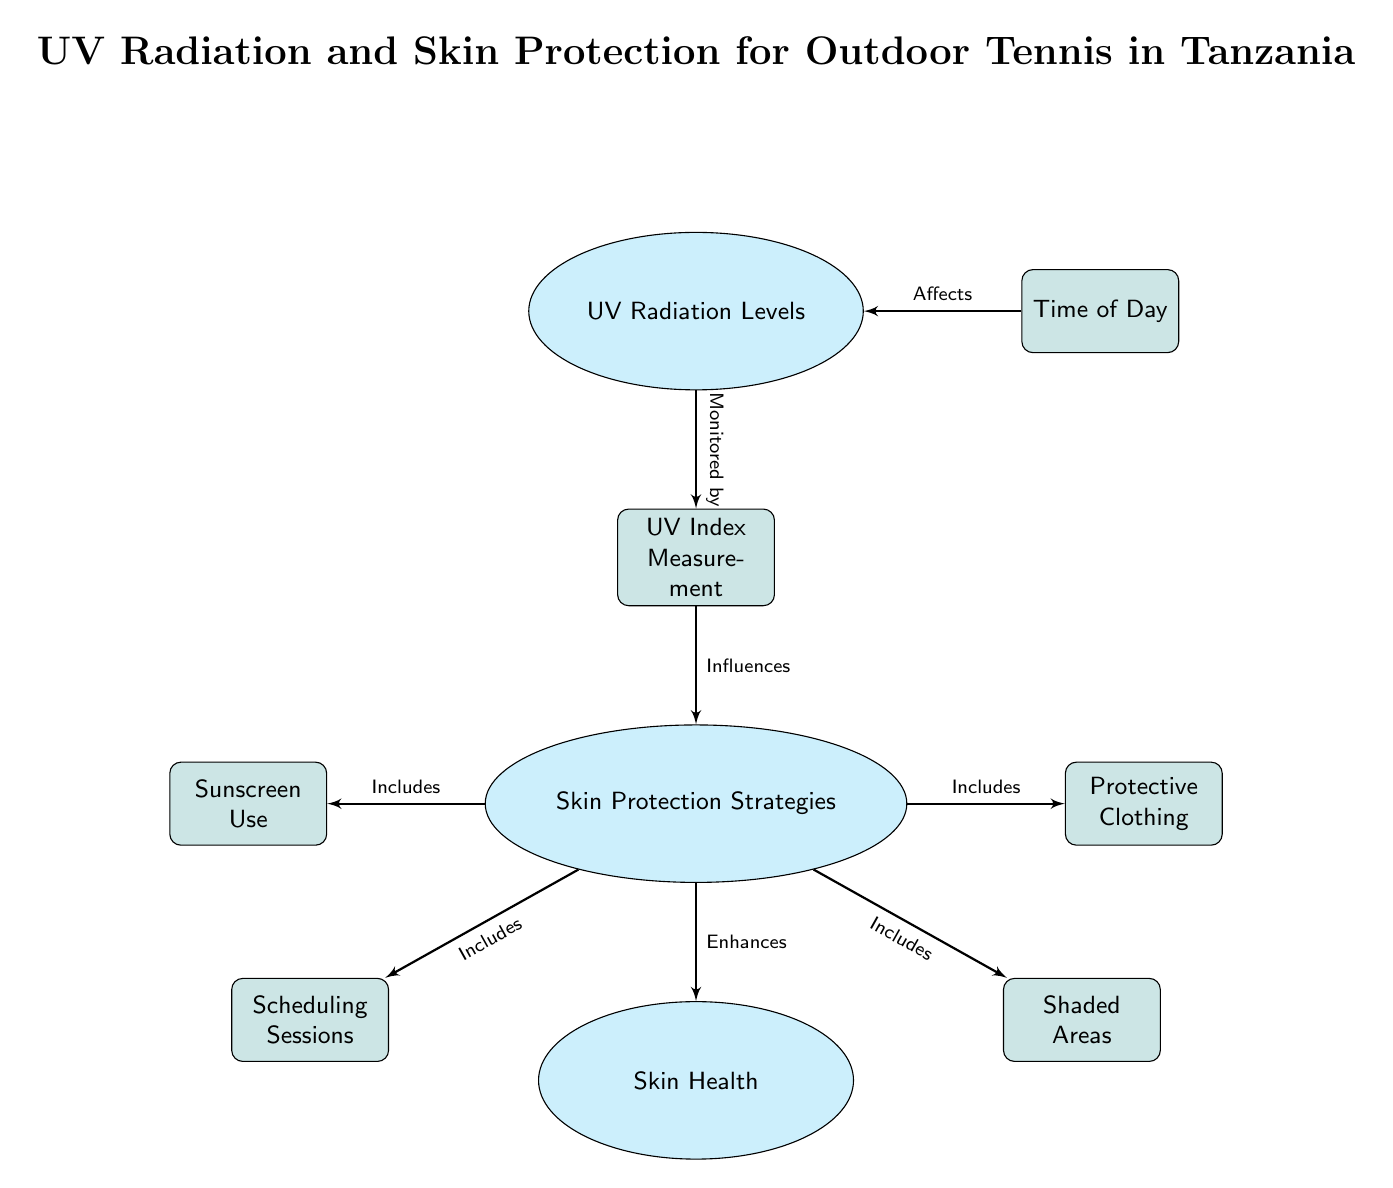What do UV Radiation Levels influence? The diagram indicates that UV Radiation Levels influence the Skin Protection Strategies node, as shown by the edge labeled "Influences."
Answer: Skin Protection Strategies How many skin protection strategies are listed in the diagram? The diagram features four specific skin protection strategies: Sunscreen Use, Protective Clothing, Scheduling Sessions, and Shaded Areas, as depicted by the blocks connected to the Protection node.
Answer: Four What affects the UV Radiation Levels? The Time of Day node is identified in the diagram as affecting the UV Radiation Levels, as indicated by the edge labeled "Affects."
Answer: Time of Day What enhances skin health according to the diagram? From the diagram, it is evident that the Skin Protection Strategies node enhances the Skin Health node, as indicated by the edge labeled "Enhances."
Answer: Skin Protection Strategies Which element directly monitors the UV Radiation Levels? The diagram specifies that UV Index Measurement directly monitors the UV Radiation Levels, as indicated by the edge labeled "Monitored by."
Answer: UV Index Measurement If a tennis session is scheduled to avoid noon, what skin protection strategy is being employed? By referring to the diagram, avoiding noon aligns with the Scheduling Sessions strategy, which is one of the methods listed under Skin Protection Strategies.
Answer: Scheduling Sessions What type of diagram is this? This is a Natural Science Diagram, which typically represents relationships and influences between various scientific elements, as seen in its structured layout.
Answer: Natural Science Diagram Which strategy is included under Skin Protection Strategies that provides physical barrier? The Protective Clothing is explicitly indicated in the diagram as one of the strategies that offer a physical barrier against UV radiation.
Answer: Protective Clothing How many nodes are present in the diagram? By counting the visible nodes, there are a total of eight nodes present in the diagram, including the clouds and blocks.
Answer: Eight 